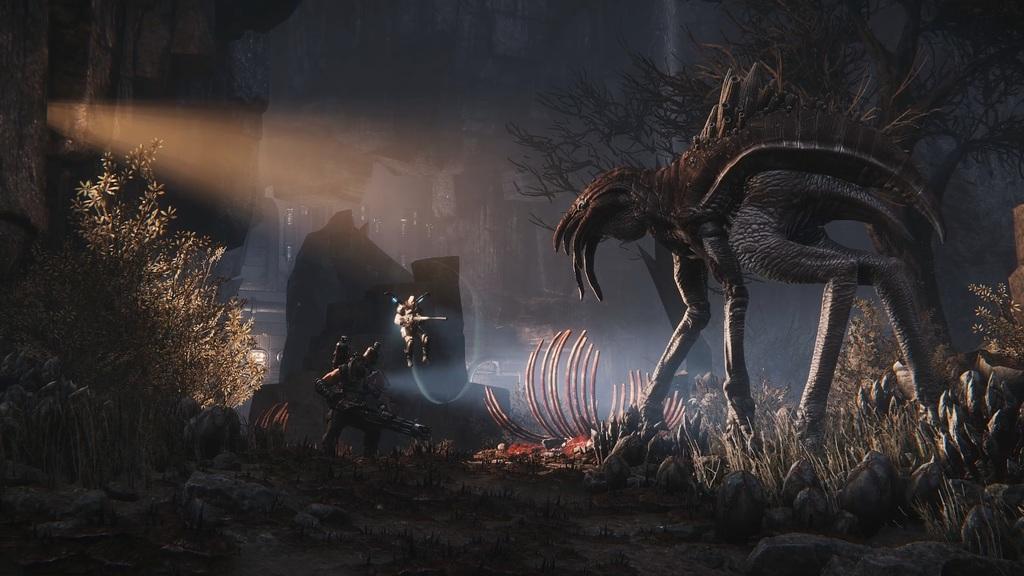Describe this image in one or two sentences. In this picture I can see there is a animal here and there are two persons standing here and there is a plant and there are buildings in the backdrop. 